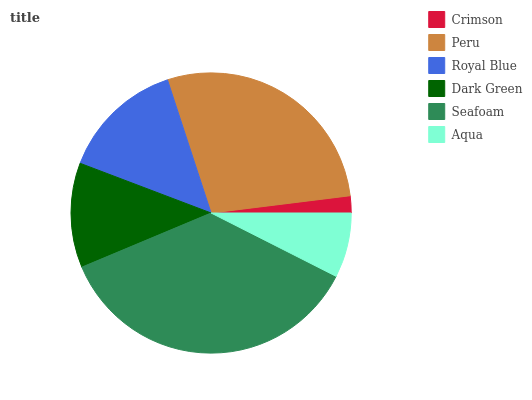Is Crimson the minimum?
Answer yes or no. Yes. Is Seafoam the maximum?
Answer yes or no. Yes. Is Peru the minimum?
Answer yes or no. No. Is Peru the maximum?
Answer yes or no. No. Is Peru greater than Crimson?
Answer yes or no. Yes. Is Crimson less than Peru?
Answer yes or no. Yes. Is Crimson greater than Peru?
Answer yes or no. No. Is Peru less than Crimson?
Answer yes or no. No. Is Royal Blue the high median?
Answer yes or no. Yes. Is Dark Green the low median?
Answer yes or no. Yes. Is Peru the high median?
Answer yes or no. No. Is Royal Blue the low median?
Answer yes or no. No. 